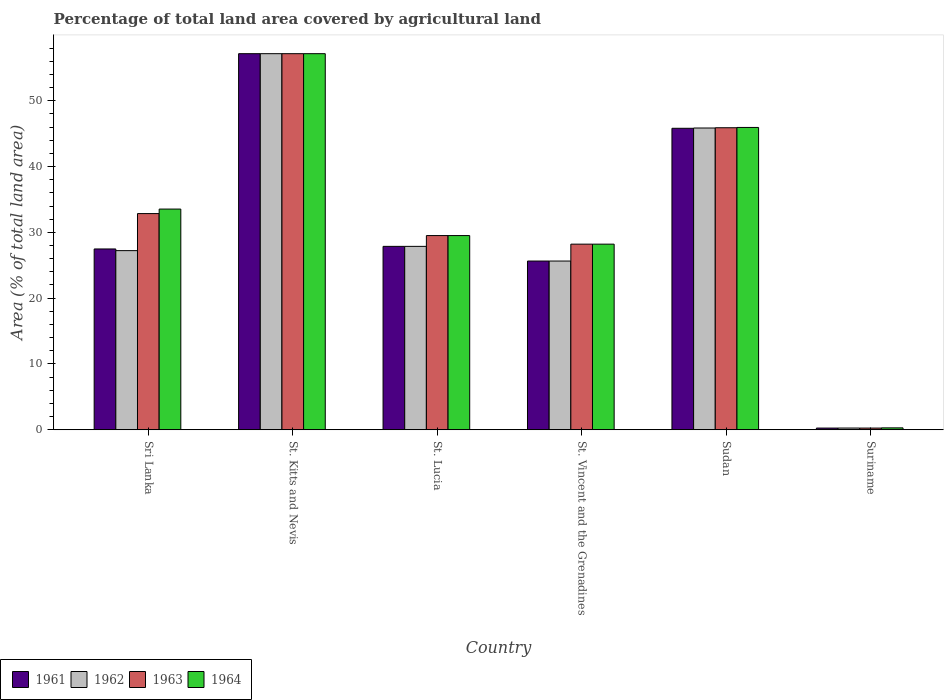How many different coloured bars are there?
Keep it short and to the point. 4. Are the number of bars on each tick of the X-axis equal?
Your answer should be compact. Yes. How many bars are there on the 1st tick from the left?
Your answer should be very brief. 4. How many bars are there on the 4th tick from the right?
Your answer should be very brief. 4. What is the label of the 5th group of bars from the left?
Offer a very short reply. Sudan. What is the percentage of agricultural land in 1961 in Sudan?
Keep it short and to the point. 45.81. Across all countries, what is the maximum percentage of agricultural land in 1962?
Ensure brevity in your answer.  57.14. Across all countries, what is the minimum percentage of agricultural land in 1964?
Your answer should be compact. 0.29. In which country was the percentage of agricultural land in 1961 maximum?
Give a very brief answer. St. Kitts and Nevis. In which country was the percentage of agricultural land in 1964 minimum?
Ensure brevity in your answer.  Suriname. What is the total percentage of agricultural land in 1961 in the graph?
Offer a terse response. 184.2. What is the difference between the percentage of agricultural land in 1963 in Sudan and that in Suriname?
Your answer should be compact. 45.63. What is the difference between the percentage of agricultural land in 1963 in Sudan and the percentage of agricultural land in 1964 in Suriname?
Provide a succinct answer. 45.6. What is the average percentage of agricultural land in 1962 per country?
Make the answer very short. 30.67. In how many countries, is the percentage of agricultural land in 1962 greater than 22 %?
Your answer should be compact. 5. What is the ratio of the percentage of agricultural land in 1961 in St. Kitts and Nevis to that in St. Vincent and the Grenadines?
Your answer should be compact. 2.23. Is the percentage of agricultural land in 1962 in Sri Lanka less than that in St. Lucia?
Provide a short and direct response. Yes. What is the difference between the highest and the second highest percentage of agricultural land in 1964?
Make the answer very short. 11.21. What is the difference between the highest and the lowest percentage of agricultural land in 1963?
Your answer should be very brief. 56.88. In how many countries, is the percentage of agricultural land in 1964 greater than the average percentage of agricultural land in 1964 taken over all countries?
Provide a short and direct response. 3. Is it the case that in every country, the sum of the percentage of agricultural land in 1962 and percentage of agricultural land in 1961 is greater than the sum of percentage of agricultural land in 1963 and percentage of agricultural land in 1964?
Make the answer very short. No. What does the 4th bar from the left in Sudan represents?
Your response must be concise. 1964. What does the 1st bar from the right in St. Kitts and Nevis represents?
Provide a succinct answer. 1964. Is it the case that in every country, the sum of the percentage of agricultural land in 1961 and percentage of agricultural land in 1963 is greater than the percentage of agricultural land in 1962?
Ensure brevity in your answer.  Yes. Are the values on the major ticks of Y-axis written in scientific E-notation?
Your answer should be very brief. No. Does the graph contain grids?
Provide a short and direct response. No. How many legend labels are there?
Make the answer very short. 4. What is the title of the graph?
Your answer should be very brief. Percentage of total land area covered by agricultural land. What is the label or title of the X-axis?
Offer a terse response. Country. What is the label or title of the Y-axis?
Your answer should be compact. Area (% of total land area). What is the Area (% of total land area) in 1961 in Sri Lanka?
Offer a very short reply. 27.48. What is the Area (% of total land area) in 1962 in Sri Lanka?
Your response must be concise. 27.22. What is the Area (% of total land area) of 1963 in Sri Lanka?
Provide a succinct answer. 32.85. What is the Area (% of total land area) of 1964 in Sri Lanka?
Your answer should be very brief. 33.54. What is the Area (% of total land area) in 1961 in St. Kitts and Nevis?
Provide a short and direct response. 57.14. What is the Area (% of total land area) in 1962 in St. Kitts and Nevis?
Your answer should be compact. 57.14. What is the Area (% of total land area) of 1963 in St. Kitts and Nevis?
Offer a terse response. 57.14. What is the Area (% of total land area) in 1964 in St. Kitts and Nevis?
Keep it short and to the point. 57.14. What is the Area (% of total land area) in 1961 in St. Lucia?
Give a very brief answer. 27.87. What is the Area (% of total land area) of 1962 in St. Lucia?
Make the answer very short. 27.87. What is the Area (% of total land area) of 1963 in St. Lucia?
Provide a succinct answer. 29.51. What is the Area (% of total land area) of 1964 in St. Lucia?
Your response must be concise. 29.51. What is the Area (% of total land area) of 1961 in St. Vincent and the Grenadines?
Your answer should be very brief. 25.64. What is the Area (% of total land area) in 1962 in St. Vincent and the Grenadines?
Your answer should be compact. 25.64. What is the Area (% of total land area) in 1963 in St. Vincent and the Grenadines?
Your answer should be compact. 28.21. What is the Area (% of total land area) of 1964 in St. Vincent and the Grenadines?
Ensure brevity in your answer.  28.21. What is the Area (% of total land area) in 1961 in Sudan?
Offer a terse response. 45.81. What is the Area (% of total land area) of 1962 in Sudan?
Provide a short and direct response. 45.85. What is the Area (% of total land area) of 1963 in Sudan?
Provide a succinct answer. 45.89. What is the Area (% of total land area) of 1964 in Sudan?
Keep it short and to the point. 45.94. What is the Area (% of total land area) in 1961 in Suriname?
Give a very brief answer. 0.26. What is the Area (% of total land area) in 1962 in Suriname?
Provide a succinct answer. 0.27. What is the Area (% of total land area) in 1963 in Suriname?
Your answer should be compact. 0.26. What is the Area (% of total land area) of 1964 in Suriname?
Offer a very short reply. 0.29. Across all countries, what is the maximum Area (% of total land area) of 1961?
Give a very brief answer. 57.14. Across all countries, what is the maximum Area (% of total land area) in 1962?
Offer a very short reply. 57.14. Across all countries, what is the maximum Area (% of total land area) of 1963?
Your answer should be very brief. 57.14. Across all countries, what is the maximum Area (% of total land area) in 1964?
Make the answer very short. 57.14. Across all countries, what is the minimum Area (% of total land area) in 1961?
Ensure brevity in your answer.  0.26. Across all countries, what is the minimum Area (% of total land area) in 1962?
Your response must be concise. 0.27. Across all countries, what is the minimum Area (% of total land area) of 1963?
Ensure brevity in your answer.  0.26. Across all countries, what is the minimum Area (% of total land area) in 1964?
Your answer should be compact. 0.29. What is the total Area (% of total land area) in 1961 in the graph?
Give a very brief answer. 184.2. What is the total Area (% of total land area) of 1962 in the graph?
Your answer should be very brief. 183.99. What is the total Area (% of total land area) of 1963 in the graph?
Provide a short and direct response. 193.86. What is the total Area (% of total land area) in 1964 in the graph?
Keep it short and to the point. 194.62. What is the difference between the Area (% of total land area) of 1961 in Sri Lanka and that in St. Kitts and Nevis?
Give a very brief answer. -29.67. What is the difference between the Area (% of total land area) of 1962 in Sri Lanka and that in St. Kitts and Nevis?
Make the answer very short. -29.92. What is the difference between the Area (% of total land area) of 1963 in Sri Lanka and that in St. Kitts and Nevis?
Provide a short and direct response. -24.29. What is the difference between the Area (% of total land area) of 1964 in Sri Lanka and that in St. Kitts and Nevis?
Offer a very short reply. -23.61. What is the difference between the Area (% of total land area) in 1961 in Sri Lanka and that in St. Lucia?
Offer a very short reply. -0.39. What is the difference between the Area (% of total land area) in 1962 in Sri Lanka and that in St. Lucia?
Provide a short and direct response. -0.65. What is the difference between the Area (% of total land area) of 1963 in Sri Lanka and that in St. Lucia?
Your answer should be compact. 3.34. What is the difference between the Area (% of total land area) in 1964 in Sri Lanka and that in St. Lucia?
Your answer should be compact. 4.03. What is the difference between the Area (% of total land area) in 1961 in Sri Lanka and that in St. Vincent and the Grenadines?
Offer a terse response. 1.83. What is the difference between the Area (% of total land area) of 1962 in Sri Lanka and that in St. Vincent and the Grenadines?
Provide a short and direct response. 1.58. What is the difference between the Area (% of total land area) in 1963 in Sri Lanka and that in St. Vincent and the Grenadines?
Offer a terse response. 4.64. What is the difference between the Area (% of total land area) of 1964 in Sri Lanka and that in St. Vincent and the Grenadines?
Provide a short and direct response. 5.33. What is the difference between the Area (% of total land area) of 1961 in Sri Lanka and that in Sudan?
Offer a terse response. -18.33. What is the difference between the Area (% of total land area) in 1962 in Sri Lanka and that in Sudan?
Give a very brief answer. -18.63. What is the difference between the Area (% of total land area) in 1963 in Sri Lanka and that in Sudan?
Make the answer very short. -13.04. What is the difference between the Area (% of total land area) of 1964 in Sri Lanka and that in Sudan?
Give a very brief answer. -12.4. What is the difference between the Area (% of total land area) of 1961 in Sri Lanka and that in Suriname?
Ensure brevity in your answer.  27.21. What is the difference between the Area (% of total land area) in 1962 in Sri Lanka and that in Suriname?
Provide a succinct answer. 26.95. What is the difference between the Area (% of total land area) in 1963 in Sri Lanka and that in Suriname?
Provide a succinct answer. 32.59. What is the difference between the Area (% of total land area) in 1964 in Sri Lanka and that in Suriname?
Ensure brevity in your answer.  33.24. What is the difference between the Area (% of total land area) in 1961 in St. Kitts and Nevis and that in St. Lucia?
Give a very brief answer. 29.27. What is the difference between the Area (% of total land area) in 1962 in St. Kitts and Nevis and that in St. Lucia?
Ensure brevity in your answer.  29.27. What is the difference between the Area (% of total land area) of 1963 in St. Kitts and Nevis and that in St. Lucia?
Provide a short and direct response. 27.63. What is the difference between the Area (% of total land area) of 1964 in St. Kitts and Nevis and that in St. Lucia?
Provide a short and direct response. 27.63. What is the difference between the Area (% of total land area) in 1961 in St. Kitts and Nevis and that in St. Vincent and the Grenadines?
Ensure brevity in your answer.  31.5. What is the difference between the Area (% of total land area) of 1962 in St. Kitts and Nevis and that in St. Vincent and the Grenadines?
Give a very brief answer. 31.5. What is the difference between the Area (% of total land area) of 1963 in St. Kitts and Nevis and that in St. Vincent and the Grenadines?
Provide a short and direct response. 28.94. What is the difference between the Area (% of total land area) in 1964 in St. Kitts and Nevis and that in St. Vincent and the Grenadines?
Give a very brief answer. 28.94. What is the difference between the Area (% of total land area) in 1961 in St. Kitts and Nevis and that in Sudan?
Your response must be concise. 11.33. What is the difference between the Area (% of total land area) of 1962 in St. Kitts and Nevis and that in Sudan?
Ensure brevity in your answer.  11.29. What is the difference between the Area (% of total land area) in 1963 in St. Kitts and Nevis and that in Sudan?
Make the answer very short. 11.25. What is the difference between the Area (% of total land area) in 1964 in St. Kitts and Nevis and that in Sudan?
Ensure brevity in your answer.  11.21. What is the difference between the Area (% of total land area) of 1961 in St. Kitts and Nevis and that in Suriname?
Your answer should be very brief. 56.88. What is the difference between the Area (% of total land area) of 1962 in St. Kitts and Nevis and that in Suriname?
Give a very brief answer. 56.87. What is the difference between the Area (% of total land area) in 1963 in St. Kitts and Nevis and that in Suriname?
Your answer should be very brief. 56.88. What is the difference between the Area (% of total land area) of 1964 in St. Kitts and Nevis and that in Suriname?
Give a very brief answer. 56.85. What is the difference between the Area (% of total land area) in 1961 in St. Lucia and that in St. Vincent and the Grenadines?
Your response must be concise. 2.23. What is the difference between the Area (% of total land area) in 1962 in St. Lucia and that in St. Vincent and the Grenadines?
Your answer should be compact. 2.23. What is the difference between the Area (% of total land area) in 1963 in St. Lucia and that in St. Vincent and the Grenadines?
Offer a very short reply. 1.3. What is the difference between the Area (% of total land area) in 1964 in St. Lucia and that in St. Vincent and the Grenadines?
Offer a very short reply. 1.3. What is the difference between the Area (% of total land area) of 1961 in St. Lucia and that in Sudan?
Ensure brevity in your answer.  -17.94. What is the difference between the Area (% of total land area) in 1962 in St. Lucia and that in Sudan?
Ensure brevity in your answer.  -17.98. What is the difference between the Area (% of total land area) in 1963 in St. Lucia and that in Sudan?
Your answer should be compact. -16.38. What is the difference between the Area (% of total land area) in 1964 in St. Lucia and that in Sudan?
Provide a short and direct response. -16.43. What is the difference between the Area (% of total land area) of 1961 in St. Lucia and that in Suriname?
Provide a short and direct response. 27.61. What is the difference between the Area (% of total land area) of 1962 in St. Lucia and that in Suriname?
Your response must be concise. 27.6. What is the difference between the Area (% of total land area) in 1963 in St. Lucia and that in Suriname?
Provide a short and direct response. 29.25. What is the difference between the Area (% of total land area) in 1964 in St. Lucia and that in Suriname?
Provide a succinct answer. 29.21. What is the difference between the Area (% of total land area) in 1961 in St. Vincent and the Grenadines and that in Sudan?
Offer a very short reply. -20.17. What is the difference between the Area (% of total land area) of 1962 in St. Vincent and the Grenadines and that in Sudan?
Make the answer very short. -20.21. What is the difference between the Area (% of total land area) in 1963 in St. Vincent and the Grenadines and that in Sudan?
Provide a short and direct response. -17.69. What is the difference between the Area (% of total land area) in 1964 in St. Vincent and the Grenadines and that in Sudan?
Give a very brief answer. -17.73. What is the difference between the Area (% of total land area) of 1961 in St. Vincent and the Grenadines and that in Suriname?
Offer a terse response. 25.38. What is the difference between the Area (% of total land area) of 1962 in St. Vincent and the Grenadines and that in Suriname?
Your response must be concise. 25.37. What is the difference between the Area (% of total land area) in 1963 in St. Vincent and the Grenadines and that in Suriname?
Offer a terse response. 27.94. What is the difference between the Area (% of total land area) in 1964 in St. Vincent and the Grenadines and that in Suriname?
Your answer should be very brief. 27.91. What is the difference between the Area (% of total land area) of 1961 in Sudan and that in Suriname?
Offer a very short reply. 45.55. What is the difference between the Area (% of total land area) of 1962 in Sudan and that in Suriname?
Your response must be concise. 45.58. What is the difference between the Area (% of total land area) in 1963 in Sudan and that in Suriname?
Your answer should be compact. 45.63. What is the difference between the Area (% of total land area) of 1964 in Sudan and that in Suriname?
Your answer should be compact. 45.64. What is the difference between the Area (% of total land area) of 1961 in Sri Lanka and the Area (% of total land area) of 1962 in St. Kitts and Nevis?
Give a very brief answer. -29.67. What is the difference between the Area (% of total land area) in 1961 in Sri Lanka and the Area (% of total land area) in 1963 in St. Kitts and Nevis?
Offer a terse response. -29.67. What is the difference between the Area (% of total land area) in 1961 in Sri Lanka and the Area (% of total land area) in 1964 in St. Kitts and Nevis?
Offer a very short reply. -29.67. What is the difference between the Area (% of total land area) of 1962 in Sri Lanka and the Area (% of total land area) of 1963 in St. Kitts and Nevis?
Your response must be concise. -29.92. What is the difference between the Area (% of total land area) of 1962 in Sri Lanka and the Area (% of total land area) of 1964 in St. Kitts and Nevis?
Provide a succinct answer. -29.92. What is the difference between the Area (% of total land area) of 1963 in Sri Lanka and the Area (% of total land area) of 1964 in St. Kitts and Nevis?
Provide a short and direct response. -24.29. What is the difference between the Area (% of total land area) in 1961 in Sri Lanka and the Area (% of total land area) in 1962 in St. Lucia?
Your response must be concise. -0.39. What is the difference between the Area (% of total land area) in 1961 in Sri Lanka and the Area (% of total land area) in 1963 in St. Lucia?
Keep it short and to the point. -2.03. What is the difference between the Area (% of total land area) in 1961 in Sri Lanka and the Area (% of total land area) in 1964 in St. Lucia?
Ensure brevity in your answer.  -2.03. What is the difference between the Area (% of total land area) of 1962 in Sri Lanka and the Area (% of total land area) of 1963 in St. Lucia?
Your response must be concise. -2.29. What is the difference between the Area (% of total land area) of 1962 in Sri Lanka and the Area (% of total land area) of 1964 in St. Lucia?
Offer a very short reply. -2.29. What is the difference between the Area (% of total land area) in 1963 in Sri Lanka and the Area (% of total land area) in 1964 in St. Lucia?
Your response must be concise. 3.34. What is the difference between the Area (% of total land area) in 1961 in Sri Lanka and the Area (% of total land area) in 1962 in St. Vincent and the Grenadines?
Give a very brief answer. 1.83. What is the difference between the Area (% of total land area) of 1961 in Sri Lanka and the Area (% of total land area) of 1963 in St. Vincent and the Grenadines?
Offer a very short reply. -0.73. What is the difference between the Area (% of total land area) of 1961 in Sri Lanka and the Area (% of total land area) of 1964 in St. Vincent and the Grenadines?
Ensure brevity in your answer.  -0.73. What is the difference between the Area (% of total land area) of 1962 in Sri Lanka and the Area (% of total land area) of 1963 in St. Vincent and the Grenadines?
Ensure brevity in your answer.  -0.98. What is the difference between the Area (% of total land area) in 1962 in Sri Lanka and the Area (% of total land area) in 1964 in St. Vincent and the Grenadines?
Your response must be concise. -0.98. What is the difference between the Area (% of total land area) in 1963 in Sri Lanka and the Area (% of total land area) in 1964 in St. Vincent and the Grenadines?
Offer a terse response. 4.64. What is the difference between the Area (% of total land area) of 1961 in Sri Lanka and the Area (% of total land area) of 1962 in Sudan?
Your answer should be very brief. -18.37. What is the difference between the Area (% of total land area) in 1961 in Sri Lanka and the Area (% of total land area) in 1963 in Sudan?
Keep it short and to the point. -18.42. What is the difference between the Area (% of total land area) in 1961 in Sri Lanka and the Area (% of total land area) in 1964 in Sudan?
Provide a short and direct response. -18.46. What is the difference between the Area (% of total land area) of 1962 in Sri Lanka and the Area (% of total land area) of 1963 in Sudan?
Your answer should be very brief. -18.67. What is the difference between the Area (% of total land area) in 1962 in Sri Lanka and the Area (% of total land area) in 1964 in Sudan?
Provide a short and direct response. -18.71. What is the difference between the Area (% of total land area) of 1963 in Sri Lanka and the Area (% of total land area) of 1964 in Sudan?
Give a very brief answer. -13.09. What is the difference between the Area (% of total land area) in 1961 in Sri Lanka and the Area (% of total land area) in 1962 in Suriname?
Make the answer very short. 27.21. What is the difference between the Area (% of total land area) in 1961 in Sri Lanka and the Area (% of total land area) in 1963 in Suriname?
Your response must be concise. 27.21. What is the difference between the Area (% of total land area) of 1961 in Sri Lanka and the Area (% of total land area) of 1964 in Suriname?
Keep it short and to the point. 27.18. What is the difference between the Area (% of total land area) of 1962 in Sri Lanka and the Area (% of total land area) of 1963 in Suriname?
Keep it short and to the point. 26.96. What is the difference between the Area (% of total land area) of 1962 in Sri Lanka and the Area (% of total land area) of 1964 in Suriname?
Make the answer very short. 26.93. What is the difference between the Area (% of total land area) in 1963 in Sri Lanka and the Area (% of total land area) in 1964 in Suriname?
Make the answer very short. 32.55. What is the difference between the Area (% of total land area) in 1961 in St. Kitts and Nevis and the Area (% of total land area) in 1962 in St. Lucia?
Your answer should be compact. 29.27. What is the difference between the Area (% of total land area) of 1961 in St. Kitts and Nevis and the Area (% of total land area) of 1963 in St. Lucia?
Your answer should be compact. 27.63. What is the difference between the Area (% of total land area) in 1961 in St. Kitts and Nevis and the Area (% of total land area) in 1964 in St. Lucia?
Offer a terse response. 27.63. What is the difference between the Area (% of total land area) of 1962 in St. Kitts and Nevis and the Area (% of total land area) of 1963 in St. Lucia?
Offer a terse response. 27.63. What is the difference between the Area (% of total land area) in 1962 in St. Kitts and Nevis and the Area (% of total land area) in 1964 in St. Lucia?
Provide a short and direct response. 27.63. What is the difference between the Area (% of total land area) in 1963 in St. Kitts and Nevis and the Area (% of total land area) in 1964 in St. Lucia?
Provide a short and direct response. 27.63. What is the difference between the Area (% of total land area) of 1961 in St. Kitts and Nevis and the Area (% of total land area) of 1962 in St. Vincent and the Grenadines?
Provide a short and direct response. 31.5. What is the difference between the Area (% of total land area) of 1961 in St. Kitts and Nevis and the Area (% of total land area) of 1963 in St. Vincent and the Grenadines?
Keep it short and to the point. 28.94. What is the difference between the Area (% of total land area) in 1961 in St. Kitts and Nevis and the Area (% of total land area) in 1964 in St. Vincent and the Grenadines?
Your response must be concise. 28.94. What is the difference between the Area (% of total land area) of 1962 in St. Kitts and Nevis and the Area (% of total land area) of 1963 in St. Vincent and the Grenadines?
Provide a succinct answer. 28.94. What is the difference between the Area (% of total land area) in 1962 in St. Kitts and Nevis and the Area (% of total land area) in 1964 in St. Vincent and the Grenadines?
Your response must be concise. 28.94. What is the difference between the Area (% of total land area) of 1963 in St. Kitts and Nevis and the Area (% of total land area) of 1964 in St. Vincent and the Grenadines?
Offer a very short reply. 28.94. What is the difference between the Area (% of total land area) of 1961 in St. Kitts and Nevis and the Area (% of total land area) of 1962 in Sudan?
Give a very brief answer. 11.29. What is the difference between the Area (% of total land area) in 1961 in St. Kitts and Nevis and the Area (% of total land area) in 1963 in Sudan?
Provide a succinct answer. 11.25. What is the difference between the Area (% of total land area) of 1961 in St. Kitts and Nevis and the Area (% of total land area) of 1964 in Sudan?
Ensure brevity in your answer.  11.21. What is the difference between the Area (% of total land area) in 1962 in St. Kitts and Nevis and the Area (% of total land area) in 1963 in Sudan?
Offer a terse response. 11.25. What is the difference between the Area (% of total land area) in 1962 in St. Kitts and Nevis and the Area (% of total land area) in 1964 in Sudan?
Provide a succinct answer. 11.21. What is the difference between the Area (% of total land area) of 1963 in St. Kitts and Nevis and the Area (% of total land area) of 1964 in Sudan?
Ensure brevity in your answer.  11.21. What is the difference between the Area (% of total land area) in 1961 in St. Kitts and Nevis and the Area (% of total land area) in 1962 in Suriname?
Your answer should be very brief. 56.87. What is the difference between the Area (% of total land area) in 1961 in St. Kitts and Nevis and the Area (% of total land area) in 1963 in Suriname?
Keep it short and to the point. 56.88. What is the difference between the Area (% of total land area) of 1961 in St. Kitts and Nevis and the Area (% of total land area) of 1964 in Suriname?
Give a very brief answer. 56.85. What is the difference between the Area (% of total land area) in 1962 in St. Kitts and Nevis and the Area (% of total land area) in 1963 in Suriname?
Make the answer very short. 56.88. What is the difference between the Area (% of total land area) of 1962 in St. Kitts and Nevis and the Area (% of total land area) of 1964 in Suriname?
Make the answer very short. 56.85. What is the difference between the Area (% of total land area) of 1963 in St. Kitts and Nevis and the Area (% of total land area) of 1964 in Suriname?
Make the answer very short. 56.85. What is the difference between the Area (% of total land area) in 1961 in St. Lucia and the Area (% of total land area) in 1962 in St. Vincent and the Grenadines?
Make the answer very short. 2.23. What is the difference between the Area (% of total land area) in 1961 in St. Lucia and the Area (% of total land area) in 1963 in St. Vincent and the Grenadines?
Ensure brevity in your answer.  -0.34. What is the difference between the Area (% of total land area) of 1961 in St. Lucia and the Area (% of total land area) of 1964 in St. Vincent and the Grenadines?
Ensure brevity in your answer.  -0.34. What is the difference between the Area (% of total land area) in 1962 in St. Lucia and the Area (% of total land area) in 1963 in St. Vincent and the Grenadines?
Offer a very short reply. -0.34. What is the difference between the Area (% of total land area) in 1962 in St. Lucia and the Area (% of total land area) in 1964 in St. Vincent and the Grenadines?
Your response must be concise. -0.34. What is the difference between the Area (% of total land area) in 1963 in St. Lucia and the Area (% of total land area) in 1964 in St. Vincent and the Grenadines?
Your answer should be very brief. 1.3. What is the difference between the Area (% of total land area) in 1961 in St. Lucia and the Area (% of total land area) in 1962 in Sudan?
Give a very brief answer. -17.98. What is the difference between the Area (% of total land area) of 1961 in St. Lucia and the Area (% of total land area) of 1963 in Sudan?
Your answer should be very brief. -18.02. What is the difference between the Area (% of total land area) of 1961 in St. Lucia and the Area (% of total land area) of 1964 in Sudan?
Offer a very short reply. -18.07. What is the difference between the Area (% of total land area) in 1962 in St. Lucia and the Area (% of total land area) in 1963 in Sudan?
Provide a short and direct response. -18.02. What is the difference between the Area (% of total land area) in 1962 in St. Lucia and the Area (% of total land area) in 1964 in Sudan?
Your answer should be compact. -18.07. What is the difference between the Area (% of total land area) of 1963 in St. Lucia and the Area (% of total land area) of 1964 in Sudan?
Your answer should be compact. -16.43. What is the difference between the Area (% of total land area) in 1961 in St. Lucia and the Area (% of total land area) in 1962 in Suriname?
Provide a short and direct response. 27.6. What is the difference between the Area (% of total land area) in 1961 in St. Lucia and the Area (% of total land area) in 1963 in Suriname?
Offer a terse response. 27.61. What is the difference between the Area (% of total land area) of 1961 in St. Lucia and the Area (% of total land area) of 1964 in Suriname?
Keep it short and to the point. 27.57. What is the difference between the Area (% of total land area) of 1962 in St. Lucia and the Area (% of total land area) of 1963 in Suriname?
Your answer should be very brief. 27.61. What is the difference between the Area (% of total land area) of 1962 in St. Lucia and the Area (% of total land area) of 1964 in Suriname?
Give a very brief answer. 27.57. What is the difference between the Area (% of total land area) of 1963 in St. Lucia and the Area (% of total land area) of 1964 in Suriname?
Provide a succinct answer. 29.21. What is the difference between the Area (% of total land area) of 1961 in St. Vincent and the Grenadines and the Area (% of total land area) of 1962 in Sudan?
Keep it short and to the point. -20.21. What is the difference between the Area (% of total land area) in 1961 in St. Vincent and the Grenadines and the Area (% of total land area) in 1963 in Sudan?
Ensure brevity in your answer.  -20.25. What is the difference between the Area (% of total land area) of 1961 in St. Vincent and the Grenadines and the Area (% of total land area) of 1964 in Sudan?
Provide a short and direct response. -20.29. What is the difference between the Area (% of total land area) in 1962 in St. Vincent and the Grenadines and the Area (% of total land area) in 1963 in Sudan?
Your response must be concise. -20.25. What is the difference between the Area (% of total land area) of 1962 in St. Vincent and the Grenadines and the Area (% of total land area) of 1964 in Sudan?
Ensure brevity in your answer.  -20.29. What is the difference between the Area (% of total land area) in 1963 in St. Vincent and the Grenadines and the Area (% of total land area) in 1964 in Sudan?
Your answer should be compact. -17.73. What is the difference between the Area (% of total land area) of 1961 in St. Vincent and the Grenadines and the Area (% of total land area) of 1962 in Suriname?
Keep it short and to the point. 25.37. What is the difference between the Area (% of total land area) in 1961 in St. Vincent and the Grenadines and the Area (% of total land area) in 1963 in Suriname?
Your answer should be very brief. 25.38. What is the difference between the Area (% of total land area) of 1961 in St. Vincent and the Grenadines and the Area (% of total land area) of 1964 in Suriname?
Make the answer very short. 25.35. What is the difference between the Area (% of total land area) of 1962 in St. Vincent and the Grenadines and the Area (% of total land area) of 1963 in Suriname?
Make the answer very short. 25.38. What is the difference between the Area (% of total land area) in 1962 in St. Vincent and the Grenadines and the Area (% of total land area) in 1964 in Suriname?
Keep it short and to the point. 25.35. What is the difference between the Area (% of total land area) of 1963 in St. Vincent and the Grenadines and the Area (% of total land area) of 1964 in Suriname?
Your response must be concise. 27.91. What is the difference between the Area (% of total land area) in 1961 in Sudan and the Area (% of total land area) in 1962 in Suriname?
Your answer should be compact. 45.54. What is the difference between the Area (% of total land area) of 1961 in Sudan and the Area (% of total land area) of 1963 in Suriname?
Provide a short and direct response. 45.55. What is the difference between the Area (% of total land area) of 1961 in Sudan and the Area (% of total land area) of 1964 in Suriname?
Provide a short and direct response. 45.51. What is the difference between the Area (% of total land area) of 1962 in Sudan and the Area (% of total land area) of 1963 in Suriname?
Provide a succinct answer. 45.59. What is the difference between the Area (% of total land area) of 1962 in Sudan and the Area (% of total land area) of 1964 in Suriname?
Offer a terse response. 45.56. What is the difference between the Area (% of total land area) in 1963 in Sudan and the Area (% of total land area) in 1964 in Suriname?
Your answer should be very brief. 45.6. What is the average Area (% of total land area) in 1961 per country?
Give a very brief answer. 30.7. What is the average Area (% of total land area) in 1962 per country?
Provide a short and direct response. 30.67. What is the average Area (% of total land area) in 1963 per country?
Your response must be concise. 32.31. What is the average Area (% of total land area) in 1964 per country?
Make the answer very short. 32.44. What is the difference between the Area (% of total land area) in 1961 and Area (% of total land area) in 1962 in Sri Lanka?
Provide a succinct answer. 0.26. What is the difference between the Area (% of total land area) of 1961 and Area (% of total land area) of 1963 in Sri Lanka?
Your response must be concise. -5.37. What is the difference between the Area (% of total land area) of 1961 and Area (% of total land area) of 1964 in Sri Lanka?
Ensure brevity in your answer.  -6.06. What is the difference between the Area (% of total land area) of 1962 and Area (% of total land area) of 1963 in Sri Lanka?
Your answer should be very brief. -5.63. What is the difference between the Area (% of total land area) of 1962 and Area (% of total land area) of 1964 in Sri Lanka?
Your answer should be very brief. -6.31. What is the difference between the Area (% of total land area) in 1963 and Area (% of total land area) in 1964 in Sri Lanka?
Offer a very short reply. -0.69. What is the difference between the Area (% of total land area) in 1961 and Area (% of total land area) in 1963 in St. Kitts and Nevis?
Give a very brief answer. 0. What is the difference between the Area (% of total land area) of 1961 and Area (% of total land area) of 1964 in St. Kitts and Nevis?
Offer a very short reply. 0. What is the difference between the Area (% of total land area) of 1962 and Area (% of total land area) of 1964 in St. Kitts and Nevis?
Offer a very short reply. 0. What is the difference between the Area (% of total land area) of 1963 and Area (% of total land area) of 1964 in St. Kitts and Nevis?
Your response must be concise. 0. What is the difference between the Area (% of total land area) in 1961 and Area (% of total land area) in 1962 in St. Lucia?
Provide a succinct answer. 0. What is the difference between the Area (% of total land area) in 1961 and Area (% of total land area) in 1963 in St. Lucia?
Your answer should be compact. -1.64. What is the difference between the Area (% of total land area) of 1961 and Area (% of total land area) of 1964 in St. Lucia?
Provide a short and direct response. -1.64. What is the difference between the Area (% of total land area) of 1962 and Area (% of total land area) of 1963 in St. Lucia?
Provide a short and direct response. -1.64. What is the difference between the Area (% of total land area) of 1962 and Area (% of total land area) of 1964 in St. Lucia?
Keep it short and to the point. -1.64. What is the difference between the Area (% of total land area) in 1963 and Area (% of total land area) in 1964 in St. Lucia?
Offer a very short reply. 0. What is the difference between the Area (% of total land area) in 1961 and Area (% of total land area) in 1963 in St. Vincent and the Grenadines?
Provide a succinct answer. -2.56. What is the difference between the Area (% of total land area) in 1961 and Area (% of total land area) in 1964 in St. Vincent and the Grenadines?
Provide a short and direct response. -2.56. What is the difference between the Area (% of total land area) of 1962 and Area (% of total land area) of 1963 in St. Vincent and the Grenadines?
Offer a very short reply. -2.56. What is the difference between the Area (% of total land area) in 1962 and Area (% of total land area) in 1964 in St. Vincent and the Grenadines?
Provide a succinct answer. -2.56. What is the difference between the Area (% of total land area) of 1963 and Area (% of total land area) of 1964 in St. Vincent and the Grenadines?
Make the answer very short. 0. What is the difference between the Area (% of total land area) of 1961 and Area (% of total land area) of 1962 in Sudan?
Make the answer very short. -0.04. What is the difference between the Area (% of total land area) in 1961 and Area (% of total land area) in 1963 in Sudan?
Provide a short and direct response. -0.08. What is the difference between the Area (% of total land area) of 1961 and Area (% of total land area) of 1964 in Sudan?
Give a very brief answer. -0.13. What is the difference between the Area (% of total land area) of 1962 and Area (% of total land area) of 1963 in Sudan?
Give a very brief answer. -0.04. What is the difference between the Area (% of total land area) in 1962 and Area (% of total land area) in 1964 in Sudan?
Make the answer very short. -0.09. What is the difference between the Area (% of total land area) in 1963 and Area (% of total land area) in 1964 in Sudan?
Your answer should be compact. -0.04. What is the difference between the Area (% of total land area) of 1961 and Area (% of total land area) of 1962 in Suriname?
Your answer should be compact. -0.01. What is the difference between the Area (% of total land area) in 1961 and Area (% of total land area) in 1963 in Suriname?
Your answer should be very brief. 0. What is the difference between the Area (% of total land area) of 1961 and Area (% of total land area) of 1964 in Suriname?
Give a very brief answer. -0.03. What is the difference between the Area (% of total land area) in 1962 and Area (% of total land area) in 1963 in Suriname?
Ensure brevity in your answer.  0.01. What is the difference between the Area (% of total land area) of 1962 and Area (% of total land area) of 1964 in Suriname?
Provide a short and direct response. -0.03. What is the difference between the Area (% of total land area) of 1963 and Area (% of total land area) of 1964 in Suriname?
Your answer should be compact. -0.03. What is the ratio of the Area (% of total land area) in 1961 in Sri Lanka to that in St. Kitts and Nevis?
Offer a very short reply. 0.48. What is the ratio of the Area (% of total land area) in 1962 in Sri Lanka to that in St. Kitts and Nevis?
Give a very brief answer. 0.48. What is the ratio of the Area (% of total land area) of 1963 in Sri Lanka to that in St. Kitts and Nevis?
Your answer should be compact. 0.57. What is the ratio of the Area (% of total land area) of 1964 in Sri Lanka to that in St. Kitts and Nevis?
Make the answer very short. 0.59. What is the ratio of the Area (% of total land area) in 1961 in Sri Lanka to that in St. Lucia?
Give a very brief answer. 0.99. What is the ratio of the Area (% of total land area) in 1962 in Sri Lanka to that in St. Lucia?
Keep it short and to the point. 0.98. What is the ratio of the Area (% of total land area) in 1963 in Sri Lanka to that in St. Lucia?
Give a very brief answer. 1.11. What is the ratio of the Area (% of total land area) in 1964 in Sri Lanka to that in St. Lucia?
Ensure brevity in your answer.  1.14. What is the ratio of the Area (% of total land area) in 1961 in Sri Lanka to that in St. Vincent and the Grenadines?
Ensure brevity in your answer.  1.07. What is the ratio of the Area (% of total land area) of 1962 in Sri Lanka to that in St. Vincent and the Grenadines?
Provide a short and direct response. 1.06. What is the ratio of the Area (% of total land area) in 1963 in Sri Lanka to that in St. Vincent and the Grenadines?
Provide a succinct answer. 1.16. What is the ratio of the Area (% of total land area) of 1964 in Sri Lanka to that in St. Vincent and the Grenadines?
Your answer should be very brief. 1.19. What is the ratio of the Area (% of total land area) of 1961 in Sri Lanka to that in Sudan?
Provide a short and direct response. 0.6. What is the ratio of the Area (% of total land area) of 1962 in Sri Lanka to that in Sudan?
Keep it short and to the point. 0.59. What is the ratio of the Area (% of total land area) of 1963 in Sri Lanka to that in Sudan?
Your response must be concise. 0.72. What is the ratio of the Area (% of total land area) in 1964 in Sri Lanka to that in Sudan?
Provide a succinct answer. 0.73. What is the ratio of the Area (% of total land area) of 1961 in Sri Lanka to that in Suriname?
Your response must be concise. 104.54. What is the ratio of the Area (% of total land area) of 1962 in Sri Lanka to that in Suriname?
Keep it short and to the point. 101.1. What is the ratio of the Area (% of total land area) in 1963 in Sri Lanka to that in Suriname?
Provide a succinct answer. 124.99. What is the ratio of the Area (% of total land area) of 1964 in Sri Lanka to that in Suriname?
Make the answer very short. 113.73. What is the ratio of the Area (% of total land area) in 1961 in St. Kitts and Nevis to that in St. Lucia?
Make the answer very short. 2.05. What is the ratio of the Area (% of total land area) in 1962 in St. Kitts and Nevis to that in St. Lucia?
Offer a terse response. 2.05. What is the ratio of the Area (% of total land area) in 1963 in St. Kitts and Nevis to that in St. Lucia?
Provide a succinct answer. 1.94. What is the ratio of the Area (% of total land area) of 1964 in St. Kitts and Nevis to that in St. Lucia?
Provide a succinct answer. 1.94. What is the ratio of the Area (% of total land area) of 1961 in St. Kitts and Nevis to that in St. Vincent and the Grenadines?
Provide a short and direct response. 2.23. What is the ratio of the Area (% of total land area) in 1962 in St. Kitts and Nevis to that in St. Vincent and the Grenadines?
Your response must be concise. 2.23. What is the ratio of the Area (% of total land area) in 1963 in St. Kitts and Nevis to that in St. Vincent and the Grenadines?
Offer a terse response. 2.03. What is the ratio of the Area (% of total land area) of 1964 in St. Kitts and Nevis to that in St. Vincent and the Grenadines?
Provide a short and direct response. 2.03. What is the ratio of the Area (% of total land area) of 1961 in St. Kitts and Nevis to that in Sudan?
Provide a short and direct response. 1.25. What is the ratio of the Area (% of total land area) of 1962 in St. Kitts and Nevis to that in Sudan?
Give a very brief answer. 1.25. What is the ratio of the Area (% of total land area) in 1963 in St. Kitts and Nevis to that in Sudan?
Your answer should be very brief. 1.25. What is the ratio of the Area (% of total land area) of 1964 in St. Kitts and Nevis to that in Sudan?
Keep it short and to the point. 1.24. What is the ratio of the Area (% of total land area) in 1961 in St. Kitts and Nevis to that in Suriname?
Ensure brevity in your answer.  217.42. What is the ratio of the Area (% of total land area) of 1962 in St. Kitts and Nevis to that in Suriname?
Offer a very short reply. 212.24. What is the ratio of the Area (% of total land area) of 1963 in St. Kitts and Nevis to that in Suriname?
Your response must be concise. 217.42. What is the ratio of the Area (% of total land area) of 1964 in St. Kitts and Nevis to that in Suriname?
Give a very brief answer. 193.79. What is the ratio of the Area (% of total land area) of 1961 in St. Lucia to that in St. Vincent and the Grenadines?
Your answer should be very brief. 1.09. What is the ratio of the Area (% of total land area) of 1962 in St. Lucia to that in St. Vincent and the Grenadines?
Your answer should be very brief. 1.09. What is the ratio of the Area (% of total land area) of 1963 in St. Lucia to that in St. Vincent and the Grenadines?
Provide a succinct answer. 1.05. What is the ratio of the Area (% of total land area) in 1964 in St. Lucia to that in St. Vincent and the Grenadines?
Your answer should be very brief. 1.05. What is the ratio of the Area (% of total land area) of 1961 in St. Lucia to that in Sudan?
Your answer should be compact. 0.61. What is the ratio of the Area (% of total land area) in 1962 in St. Lucia to that in Sudan?
Your answer should be compact. 0.61. What is the ratio of the Area (% of total land area) in 1963 in St. Lucia to that in Sudan?
Keep it short and to the point. 0.64. What is the ratio of the Area (% of total land area) in 1964 in St. Lucia to that in Sudan?
Offer a terse response. 0.64. What is the ratio of the Area (% of total land area) in 1961 in St. Lucia to that in Suriname?
Offer a very short reply. 106.04. What is the ratio of the Area (% of total land area) in 1962 in St. Lucia to that in Suriname?
Provide a short and direct response. 103.51. What is the ratio of the Area (% of total land area) of 1963 in St. Lucia to that in Suriname?
Give a very brief answer. 112.28. What is the ratio of the Area (% of total land area) in 1964 in St. Lucia to that in Suriname?
Your response must be concise. 100.07. What is the ratio of the Area (% of total land area) in 1961 in St. Vincent and the Grenadines to that in Sudan?
Provide a short and direct response. 0.56. What is the ratio of the Area (% of total land area) in 1962 in St. Vincent and the Grenadines to that in Sudan?
Make the answer very short. 0.56. What is the ratio of the Area (% of total land area) in 1963 in St. Vincent and the Grenadines to that in Sudan?
Keep it short and to the point. 0.61. What is the ratio of the Area (% of total land area) of 1964 in St. Vincent and the Grenadines to that in Sudan?
Your answer should be compact. 0.61. What is the ratio of the Area (% of total land area) of 1961 in St. Vincent and the Grenadines to that in Suriname?
Your response must be concise. 97.56. What is the ratio of the Area (% of total land area) in 1962 in St. Vincent and the Grenadines to that in Suriname?
Offer a very short reply. 95.24. What is the ratio of the Area (% of total land area) of 1963 in St. Vincent and the Grenadines to that in Suriname?
Your answer should be very brief. 107.32. What is the ratio of the Area (% of total land area) of 1964 in St. Vincent and the Grenadines to that in Suriname?
Provide a succinct answer. 95.65. What is the ratio of the Area (% of total land area) of 1961 in Sudan to that in Suriname?
Your answer should be compact. 174.29. What is the ratio of the Area (% of total land area) in 1962 in Sudan to that in Suriname?
Your answer should be compact. 170.3. What is the ratio of the Area (% of total land area) of 1963 in Sudan to that in Suriname?
Keep it short and to the point. 174.61. What is the ratio of the Area (% of total land area) in 1964 in Sudan to that in Suriname?
Provide a succinct answer. 155.78. What is the difference between the highest and the second highest Area (% of total land area) in 1961?
Offer a very short reply. 11.33. What is the difference between the highest and the second highest Area (% of total land area) of 1962?
Make the answer very short. 11.29. What is the difference between the highest and the second highest Area (% of total land area) of 1963?
Offer a terse response. 11.25. What is the difference between the highest and the second highest Area (% of total land area) in 1964?
Keep it short and to the point. 11.21. What is the difference between the highest and the lowest Area (% of total land area) of 1961?
Offer a terse response. 56.88. What is the difference between the highest and the lowest Area (% of total land area) in 1962?
Provide a short and direct response. 56.87. What is the difference between the highest and the lowest Area (% of total land area) in 1963?
Make the answer very short. 56.88. What is the difference between the highest and the lowest Area (% of total land area) of 1964?
Provide a succinct answer. 56.85. 